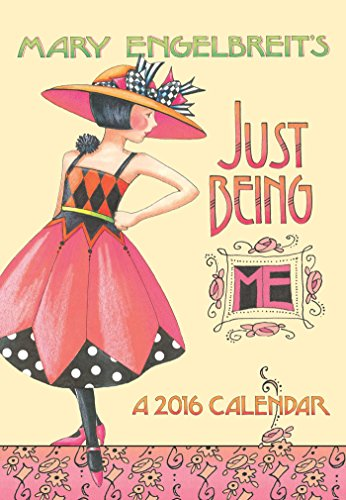Please describe the appearance and aesthetic of this book cover. The cover features a vibrant illustration of a woman in a flamboyant red and black dress with a stylish hat, evoking a whimsical and artistic vibe. The background is a soft peach color, and decorative elements like framed quotes and floral patterns enhance the playful, creative feel of the design. 